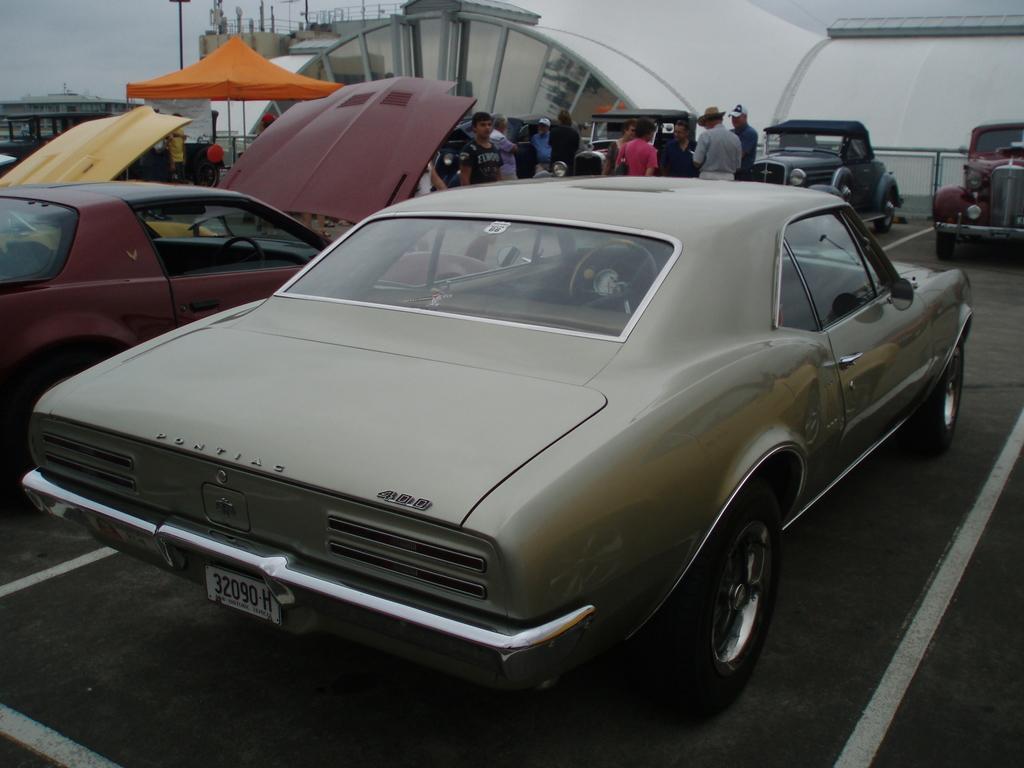Describe this image in one or two sentences. In this image I can see vehicles visible on the ground , in front of vehicles I can see persons and I can see a entrance gate visible at the top and in the top left I can see the sky and in the middle I can see orange color tint. 